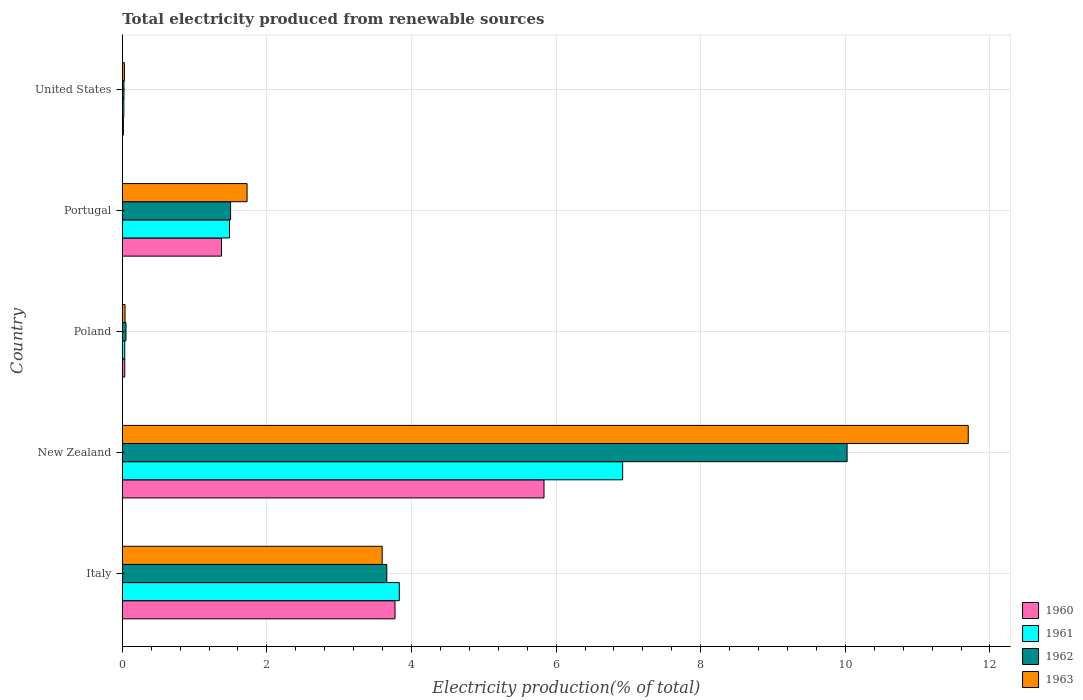How many different coloured bars are there?
Your answer should be compact. 4. How many bars are there on the 4th tick from the bottom?
Keep it short and to the point. 4. What is the label of the 4th group of bars from the top?
Provide a succinct answer. New Zealand. In how many cases, is the number of bars for a given country not equal to the number of legend labels?
Your answer should be compact. 0. What is the total electricity produced in 1963 in Italy?
Provide a succinct answer. 3.59. Across all countries, what is the maximum total electricity produced in 1963?
Your response must be concise. 11.7. Across all countries, what is the minimum total electricity produced in 1961?
Ensure brevity in your answer.  0.02. In which country was the total electricity produced in 1962 maximum?
Your answer should be very brief. New Zealand. In which country was the total electricity produced in 1962 minimum?
Offer a terse response. United States. What is the total total electricity produced in 1963 in the graph?
Your response must be concise. 17.09. What is the difference between the total electricity produced in 1960 in New Zealand and that in United States?
Ensure brevity in your answer.  5.82. What is the difference between the total electricity produced in 1963 in United States and the total electricity produced in 1960 in Italy?
Your answer should be very brief. -3.74. What is the average total electricity produced in 1960 per country?
Ensure brevity in your answer.  2.21. What is the difference between the total electricity produced in 1962 and total electricity produced in 1963 in Portugal?
Your answer should be very brief. -0.23. What is the ratio of the total electricity produced in 1960 in Poland to that in Portugal?
Keep it short and to the point. 0.02. Is the difference between the total electricity produced in 1962 in New Zealand and Poland greater than the difference between the total electricity produced in 1963 in New Zealand and Poland?
Your answer should be compact. No. What is the difference between the highest and the second highest total electricity produced in 1960?
Your response must be concise. 2.06. What is the difference between the highest and the lowest total electricity produced in 1960?
Offer a terse response. 5.82. In how many countries, is the total electricity produced in 1961 greater than the average total electricity produced in 1961 taken over all countries?
Offer a terse response. 2. Is the sum of the total electricity produced in 1963 in Italy and Poland greater than the maximum total electricity produced in 1962 across all countries?
Offer a terse response. No. Is it the case that in every country, the sum of the total electricity produced in 1962 and total electricity produced in 1960 is greater than the sum of total electricity produced in 1961 and total electricity produced in 1963?
Your answer should be very brief. No. Is it the case that in every country, the sum of the total electricity produced in 1963 and total electricity produced in 1960 is greater than the total electricity produced in 1961?
Give a very brief answer. Yes. How many countries are there in the graph?
Your answer should be very brief. 5. What is the difference between two consecutive major ticks on the X-axis?
Your response must be concise. 2. Are the values on the major ticks of X-axis written in scientific E-notation?
Your answer should be compact. No. Does the graph contain grids?
Offer a very short reply. Yes. How are the legend labels stacked?
Make the answer very short. Vertical. What is the title of the graph?
Provide a succinct answer. Total electricity produced from renewable sources. What is the label or title of the X-axis?
Keep it short and to the point. Electricity production(% of total). What is the label or title of the Y-axis?
Your answer should be very brief. Country. What is the Electricity production(% of total) of 1960 in Italy?
Keep it short and to the point. 3.77. What is the Electricity production(% of total) in 1961 in Italy?
Make the answer very short. 3.83. What is the Electricity production(% of total) in 1962 in Italy?
Offer a very short reply. 3.66. What is the Electricity production(% of total) in 1963 in Italy?
Give a very brief answer. 3.59. What is the Electricity production(% of total) of 1960 in New Zealand?
Your response must be concise. 5.83. What is the Electricity production(% of total) in 1961 in New Zealand?
Offer a terse response. 6.92. What is the Electricity production(% of total) in 1962 in New Zealand?
Ensure brevity in your answer.  10.02. What is the Electricity production(% of total) of 1963 in New Zealand?
Give a very brief answer. 11.7. What is the Electricity production(% of total) in 1960 in Poland?
Your answer should be very brief. 0.03. What is the Electricity production(% of total) of 1961 in Poland?
Your response must be concise. 0.03. What is the Electricity production(% of total) of 1962 in Poland?
Provide a succinct answer. 0.05. What is the Electricity production(% of total) of 1963 in Poland?
Keep it short and to the point. 0.04. What is the Electricity production(% of total) in 1960 in Portugal?
Keep it short and to the point. 1.37. What is the Electricity production(% of total) of 1961 in Portugal?
Give a very brief answer. 1.48. What is the Electricity production(% of total) of 1962 in Portugal?
Keep it short and to the point. 1.5. What is the Electricity production(% of total) of 1963 in Portugal?
Your answer should be very brief. 1.73. What is the Electricity production(% of total) in 1960 in United States?
Keep it short and to the point. 0.02. What is the Electricity production(% of total) in 1961 in United States?
Ensure brevity in your answer.  0.02. What is the Electricity production(% of total) in 1962 in United States?
Ensure brevity in your answer.  0.02. What is the Electricity production(% of total) of 1963 in United States?
Make the answer very short. 0.03. Across all countries, what is the maximum Electricity production(% of total) of 1960?
Provide a short and direct response. 5.83. Across all countries, what is the maximum Electricity production(% of total) in 1961?
Give a very brief answer. 6.92. Across all countries, what is the maximum Electricity production(% of total) of 1962?
Your answer should be very brief. 10.02. Across all countries, what is the maximum Electricity production(% of total) in 1963?
Your response must be concise. 11.7. Across all countries, what is the minimum Electricity production(% of total) in 1960?
Offer a very short reply. 0.02. Across all countries, what is the minimum Electricity production(% of total) in 1961?
Keep it short and to the point. 0.02. Across all countries, what is the minimum Electricity production(% of total) in 1962?
Provide a succinct answer. 0.02. Across all countries, what is the minimum Electricity production(% of total) in 1963?
Ensure brevity in your answer.  0.03. What is the total Electricity production(% of total) in 1960 in the graph?
Offer a very short reply. 11.03. What is the total Electricity production(% of total) in 1961 in the graph?
Make the answer very short. 12.29. What is the total Electricity production(% of total) of 1962 in the graph?
Keep it short and to the point. 15.25. What is the total Electricity production(% of total) in 1963 in the graph?
Provide a short and direct response. 17.09. What is the difference between the Electricity production(% of total) in 1960 in Italy and that in New Zealand?
Your response must be concise. -2.06. What is the difference between the Electricity production(% of total) in 1961 in Italy and that in New Zealand?
Make the answer very short. -3.09. What is the difference between the Electricity production(% of total) of 1962 in Italy and that in New Zealand?
Provide a succinct answer. -6.37. What is the difference between the Electricity production(% of total) of 1963 in Italy and that in New Zealand?
Your response must be concise. -8.11. What is the difference between the Electricity production(% of total) of 1960 in Italy and that in Poland?
Offer a very short reply. 3.74. What is the difference between the Electricity production(% of total) of 1961 in Italy and that in Poland?
Your answer should be compact. 3.8. What is the difference between the Electricity production(% of total) of 1962 in Italy and that in Poland?
Keep it short and to the point. 3.61. What is the difference between the Electricity production(% of total) of 1963 in Italy and that in Poland?
Give a very brief answer. 3.56. What is the difference between the Electricity production(% of total) of 1960 in Italy and that in Portugal?
Make the answer very short. 2.4. What is the difference between the Electricity production(% of total) in 1961 in Italy and that in Portugal?
Offer a terse response. 2.35. What is the difference between the Electricity production(% of total) in 1962 in Italy and that in Portugal?
Your answer should be compact. 2.16. What is the difference between the Electricity production(% of total) in 1963 in Italy and that in Portugal?
Make the answer very short. 1.87. What is the difference between the Electricity production(% of total) in 1960 in Italy and that in United States?
Provide a succinct answer. 3.76. What is the difference between the Electricity production(% of total) of 1961 in Italy and that in United States?
Offer a terse response. 3.81. What is the difference between the Electricity production(% of total) in 1962 in Italy and that in United States?
Your answer should be very brief. 3.64. What is the difference between the Electricity production(% of total) in 1963 in Italy and that in United States?
Provide a short and direct response. 3.56. What is the difference between the Electricity production(% of total) of 1960 in New Zealand and that in Poland?
Your answer should be compact. 5.8. What is the difference between the Electricity production(% of total) in 1961 in New Zealand and that in Poland?
Offer a very short reply. 6.89. What is the difference between the Electricity production(% of total) of 1962 in New Zealand and that in Poland?
Give a very brief answer. 9.97. What is the difference between the Electricity production(% of total) of 1963 in New Zealand and that in Poland?
Provide a succinct answer. 11.66. What is the difference between the Electricity production(% of total) of 1960 in New Zealand and that in Portugal?
Give a very brief answer. 4.46. What is the difference between the Electricity production(% of total) in 1961 in New Zealand and that in Portugal?
Your response must be concise. 5.44. What is the difference between the Electricity production(% of total) of 1962 in New Zealand and that in Portugal?
Your answer should be compact. 8.53. What is the difference between the Electricity production(% of total) in 1963 in New Zealand and that in Portugal?
Your answer should be compact. 9.97. What is the difference between the Electricity production(% of total) in 1960 in New Zealand and that in United States?
Your answer should be very brief. 5.82. What is the difference between the Electricity production(% of total) of 1961 in New Zealand and that in United States?
Your answer should be compact. 6.9. What is the difference between the Electricity production(% of total) of 1962 in New Zealand and that in United States?
Ensure brevity in your answer.  10. What is the difference between the Electricity production(% of total) in 1963 in New Zealand and that in United States?
Give a very brief answer. 11.67. What is the difference between the Electricity production(% of total) in 1960 in Poland and that in Portugal?
Provide a succinct answer. -1.34. What is the difference between the Electricity production(% of total) of 1961 in Poland and that in Portugal?
Offer a terse response. -1.45. What is the difference between the Electricity production(% of total) in 1962 in Poland and that in Portugal?
Offer a very short reply. -1.45. What is the difference between the Electricity production(% of total) in 1963 in Poland and that in Portugal?
Make the answer very short. -1.69. What is the difference between the Electricity production(% of total) in 1960 in Poland and that in United States?
Make the answer very short. 0.02. What is the difference between the Electricity production(% of total) in 1961 in Poland and that in United States?
Ensure brevity in your answer.  0.01. What is the difference between the Electricity production(% of total) in 1962 in Poland and that in United States?
Offer a very short reply. 0.03. What is the difference between the Electricity production(% of total) in 1963 in Poland and that in United States?
Ensure brevity in your answer.  0.01. What is the difference between the Electricity production(% of total) of 1960 in Portugal and that in United States?
Make the answer very short. 1.36. What is the difference between the Electricity production(% of total) of 1961 in Portugal and that in United States?
Provide a short and direct response. 1.46. What is the difference between the Electricity production(% of total) of 1962 in Portugal and that in United States?
Make the answer very short. 1.48. What is the difference between the Electricity production(% of total) of 1963 in Portugal and that in United States?
Provide a succinct answer. 1.7. What is the difference between the Electricity production(% of total) in 1960 in Italy and the Electricity production(% of total) in 1961 in New Zealand?
Your answer should be very brief. -3.15. What is the difference between the Electricity production(% of total) of 1960 in Italy and the Electricity production(% of total) of 1962 in New Zealand?
Provide a succinct answer. -6.25. What is the difference between the Electricity production(% of total) of 1960 in Italy and the Electricity production(% of total) of 1963 in New Zealand?
Make the answer very short. -7.93. What is the difference between the Electricity production(% of total) of 1961 in Italy and the Electricity production(% of total) of 1962 in New Zealand?
Provide a short and direct response. -6.19. What is the difference between the Electricity production(% of total) in 1961 in Italy and the Electricity production(% of total) in 1963 in New Zealand?
Offer a very short reply. -7.87. What is the difference between the Electricity production(% of total) of 1962 in Italy and the Electricity production(% of total) of 1963 in New Zealand?
Provide a short and direct response. -8.04. What is the difference between the Electricity production(% of total) in 1960 in Italy and the Electricity production(% of total) in 1961 in Poland?
Provide a short and direct response. 3.74. What is the difference between the Electricity production(% of total) of 1960 in Italy and the Electricity production(% of total) of 1962 in Poland?
Offer a terse response. 3.72. What is the difference between the Electricity production(% of total) of 1960 in Italy and the Electricity production(% of total) of 1963 in Poland?
Provide a succinct answer. 3.73. What is the difference between the Electricity production(% of total) of 1961 in Italy and the Electricity production(% of total) of 1962 in Poland?
Give a very brief answer. 3.78. What is the difference between the Electricity production(% of total) in 1961 in Italy and the Electricity production(% of total) in 1963 in Poland?
Your answer should be very brief. 3.79. What is the difference between the Electricity production(% of total) in 1962 in Italy and the Electricity production(% of total) in 1963 in Poland?
Give a very brief answer. 3.62. What is the difference between the Electricity production(% of total) of 1960 in Italy and the Electricity production(% of total) of 1961 in Portugal?
Make the answer very short. 2.29. What is the difference between the Electricity production(% of total) in 1960 in Italy and the Electricity production(% of total) in 1962 in Portugal?
Make the answer very short. 2.27. What is the difference between the Electricity production(% of total) in 1960 in Italy and the Electricity production(% of total) in 1963 in Portugal?
Your answer should be very brief. 2.05. What is the difference between the Electricity production(% of total) in 1961 in Italy and the Electricity production(% of total) in 1962 in Portugal?
Your answer should be very brief. 2.33. What is the difference between the Electricity production(% of total) in 1961 in Italy and the Electricity production(% of total) in 1963 in Portugal?
Keep it short and to the point. 2.11. What is the difference between the Electricity production(% of total) of 1962 in Italy and the Electricity production(% of total) of 1963 in Portugal?
Provide a succinct answer. 1.93. What is the difference between the Electricity production(% of total) in 1960 in Italy and the Electricity production(% of total) in 1961 in United States?
Your response must be concise. 3.75. What is the difference between the Electricity production(% of total) of 1960 in Italy and the Electricity production(% of total) of 1962 in United States?
Ensure brevity in your answer.  3.75. What is the difference between the Electricity production(% of total) in 1960 in Italy and the Electricity production(% of total) in 1963 in United States?
Ensure brevity in your answer.  3.74. What is the difference between the Electricity production(% of total) in 1961 in Italy and the Electricity production(% of total) in 1962 in United States?
Offer a terse response. 3.81. What is the difference between the Electricity production(% of total) of 1961 in Italy and the Electricity production(% of total) of 1963 in United States?
Your answer should be compact. 3.8. What is the difference between the Electricity production(% of total) in 1962 in Italy and the Electricity production(% of total) in 1963 in United States?
Provide a succinct answer. 3.63. What is the difference between the Electricity production(% of total) in 1960 in New Zealand and the Electricity production(% of total) in 1961 in Poland?
Provide a short and direct response. 5.8. What is the difference between the Electricity production(% of total) in 1960 in New Zealand and the Electricity production(% of total) in 1962 in Poland?
Provide a short and direct response. 5.78. What is the difference between the Electricity production(% of total) in 1960 in New Zealand and the Electricity production(% of total) in 1963 in Poland?
Your answer should be very brief. 5.79. What is the difference between the Electricity production(% of total) of 1961 in New Zealand and the Electricity production(% of total) of 1962 in Poland?
Make the answer very short. 6.87. What is the difference between the Electricity production(% of total) of 1961 in New Zealand and the Electricity production(% of total) of 1963 in Poland?
Your response must be concise. 6.88. What is the difference between the Electricity production(% of total) of 1962 in New Zealand and the Electricity production(% of total) of 1963 in Poland?
Keep it short and to the point. 9.99. What is the difference between the Electricity production(% of total) in 1960 in New Zealand and the Electricity production(% of total) in 1961 in Portugal?
Offer a very short reply. 4.35. What is the difference between the Electricity production(% of total) in 1960 in New Zealand and the Electricity production(% of total) in 1962 in Portugal?
Offer a very short reply. 4.33. What is the difference between the Electricity production(% of total) of 1960 in New Zealand and the Electricity production(% of total) of 1963 in Portugal?
Your answer should be compact. 4.11. What is the difference between the Electricity production(% of total) in 1961 in New Zealand and the Electricity production(% of total) in 1962 in Portugal?
Provide a short and direct response. 5.42. What is the difference between the Electricity production(% of total) of 1961 in New Zealand and the Electricity production(% of total) of 1963 in Portugal?
Provide a short and direct response. 5.19. What is the difference between the Electricity production(% of total) in 1962 in New Zealand and the Electricity production(% of total) in 1963 in Portugal?
Give a very brief answer. 8.3. What is the difference between the Electricity production(% of total) in 1960 in New Zealand and the Electricity production(% of total) in 1961 in United States?
Keep it short and to the point. 5.81. What is the difference between the Electricity production(% of total) in 1960 in New Zealand and the Electricity production(% of total) in 1962 in United States?
Your answer should be compact. 5.81. What is the difference between the Electricity production(% of total) of 1960 in New Zealand and the Electricity production(% of total) of 1963 in United States?
Offer a terse response. 5.8. What is the difference between the Electricity production(% of total) in 1961 in New Zealand and the Electricity production(% of total) in 1962 in United States?
Your answer should be compact. 6.9. What is the difference between the Electricity production(% of total) of 1961 in New Zealand and the Electricity production(% of total) of 1963 in United States?
Ensure brevity in your answer.  6.89. What is the difference between the Electricity production(% of total) of 1962 in New Zealand and the Electricity production(% of total) of 1963 in United States?
Give a very brief answer. 10. What is the difference between the Electricity production(% of total) of 1960 in Poland and the Electricity production(% of total) of 1961 in Portugal?
Provide a succinct answer. -1.45. What is the difference between the Electricity production(% of total) in 1960 in Poland and the Electricity production(% of total) in 1962 in Portugal?
Give a very brief answer. -1.46. What is the difference between the Electricity production(% of total) of 1960 in Poland and the Electricity production(% of total) of 1963 in Portugal?
Provide a succinct answer. -1.69. What is the difference between the Electricity production(% of total) of 1961 in Poland and the Electricity production(% of total) of 1962 in Portugal?
Your answer should be compact. -1.46. What is the difference between the Electricity production(% of total) of 1961 in Poland and the Electricity production(% of total) of 1963 in Portugal?
Give a very brief answer. -1.69. What is the difference between the Electricity production(% of total) of 1962 in Poland and the Electricity production(% of total) of 1963 in Portugal?
Offer a very short reply. -1.67. What is the difference between the Electricity production(% of total) in 1960 in Poland and the Electricity production(% of total) in 1961 in United States?
Keep it short and to the point. 0.01. What is the difference between the Electricity production(% of total) in 1960 in Poland and the Electricity production(% of total) in 1962 in United States?
Provide a short and direct response. 0.01. What is the difference between the Electricity production(% of total) of 1960 in Poland and the Electricity production(% of total) of 1963 in United States?
Make the answer very short. 0. What is the difference between the Electricity production(% of total) of 1961 in Poland and the Electricity production(% of total) of 1962 in United States?
Offer a terse response. 0.01. What is the difference between the Electricity production(% of total) in 1961 in Poland and the Electricity production(% of total) in 1963 in United States?
Ensure brevity in your answer.  0. What is the difference between the Electricity production(% of total) in 1962 in Poland and the Electricity production(% of total) in 1963 in United States?
Your answer should be very brief. 0.02. What is the difference between the Electricity production(% of total) in 1960 in Portugal and the Electricity production(% of total) in 1961 in United States?
Keep it short and to the point. 1.35. What is the difference between the Electricity production(% of total) in 1960 in Portugal and the Electricity production(% of total) in 1962 in United States?
Provide a short and direct response. 1.35. What is the difference between the Electricity production(% of total) of 1960 in Portugal and the Electricity production(% of total) of 1963 in United States?
Your response must be concise. 1.34. What is the difference between the Electricity production(% of total) of 1961 in Portugal and the Electricity production(% of total) of 1962 in United States?
Keep it short and to the point. 1.46. What is the difference between the Electricity production(% of total) in 1961 in Portugal and the Electricity production(% of total) in 1963 in United States?
Provide a short and direct response. 1.45. What is the difference between the Electricity production(% of total) of 1962 in Portugal and the Electricity production(% of total) of 1963 in United States?
Offer a terse response. 1.47. What is the average Electricity production(% of total) in 1960 per country?
Your answer should be compact. 2.21. What is the average Electricity production(% of total) of 1961 per country?
Ensure brevity in your answer.  2.46. What is the average Electricity production(% of total) of 1962 per country?
Provide a succinct answer. 3.05. What is the average Electricity production(% of total) of 1963 per country?
Ensure brevity in your answer.  3.42. What is the difference between the Electricity production(% of total) of 1960 and Electricity production(% of total) of 1961 in Italy?
Your response must be concise. -0.06. What is the difference between the Electricity production(% of total) of 1960 and Electricity production(% of total) of 1962 in Italy?
Provide a short and direct response. 0.11. What is the difference between the Electricity production(% of total) in 1960 and Electricity production(% of total) in 1963 in Italy?
Ensure brevity in your answer.  0.18. What is the difference between the Electricity production(% of total) of 1961 and Electricity production(% of total) of 1962 in Italy?
Your answer should be compact. 0.17. What is the difference between the Electricity production(% of total) in 1961 and Electricity production(% of total) in 1963 in Italy?
Your answer should be very brief. 0.24. What is the difference between the Electricity production(% of total) in 1962 and Electricity production(% of total) in 1963 in Italy?
Offer a very short reply. 0.06. What is the difference between the Electricity production(% of total) of 1960 and Electricity production(% of total) of 1961 in New Zealand?
Offer a terse response. -1.09. What is the difference between the Electricity production(% of total) of 1960 and Electricity production(% of total) of 1962 in New Zealand?
Keep it short and to the point. -4.19. What is the difference between the Electricity production(% of total) in 1960 and Electricity production(% of total) in 1963 in New Zealand?
Give a very brief answer. -5.87. What is the difference between the Electricity production(% of total) in 1961 and Electricity production(% of total) in 1962 in New Zealand?
Your response must be concise. -3.1. What is the difference between the Electricity production(% of total) in 1961 and Electricity production(% of total) in 1963 in New Zealand?
Your response must be concise. -4.78. What is the difference between the Electricity production(% of total) in 1962 and Electricity production(% of total) in 1963 in New Zealand?
Your answer should be compact. -1.68. What is the difference between the Electricity production(% of total) of 1960 and Electricity production(% of total) of 1961 in Poland?
Offer a terse response. 0. What is the difference between the Electricity production(% of total) in 1960 and Electricity production(% of total) in 1962 in Poland?
Offer a very short reply. -0.02. What is the difference between the Electricity production(% of total) in 1960 and Electricity production(% of total) in 1963 in Poland?
Provide a short and direct response. -0. What is the difference between the Electricity production(% of total) of 1961 and Electricity production(% of total) of 1962 in Poland?
Offer a very short reply. -0.02. What is the difference between the Electricity production(% of total) in 1961 and Electricity production(% of total) in 1963 in Poland?
Your answer should be compact. -0. What is the difference between the Electricity production(% of total) of 1962 and Electricity production(% of total) of 1963 in Poland?
Provide a succinct answer. 0.01. What is the difference between the Electricity production(% of total) in 1960 and Electricity production(% of total) in 1961 in Portugal?
Give a very brief answer. -0.11. What is the difference between the Electricity production(% of total) of 1960 and Electricity production(% of total) of 1962 in Portugal?
Make the answer very short. -0.13. What is the difference between the Electricity production(% of total) in 1960 and Electricity production(% of total) in 1963 in Portugal?
Make the answer very short. -0.35. What is the difference between the Electricity production(% of total) in 1961 and Electricity production(% of total) in 1962 in Portugal?
Give a very brief answer. -0.02. What is the difference between the Electricity production(% of total) in 1961 and Electricity production(% of total) in 1963 in Portugal?
Your response must be concise. -0.24. What is the difference between the Electricity production(% of total) of 1962 and Electricity production(% of total) of 1963 in Portugal?
Keep it short and to the point. -0.23. What is the difference between the Electricity production(% of total) of 1960 and Electricity production(% of total) of 1961 in United States?
Make the answer very short. -0.01. What is the difference between the Electricity production(% of total) in 1960 and Electricity production(% of total) in 1962 in United States?
Your answer should be compact. -0.01. What is the difference between the Electricity production(% of total) in 1960 and Electricity production(% of total) in 1963 in United States?
Keep it short and to the point. -0.01. What is the difference between the Electricity production(% of total) of 1961 and Electricity production(% of total) of 1962 in United States?
Provide a succinct answer. -0. What is the difference between the Electricity production(% of total) in 1961 and Electricity production(% of total) in 1963 in United States?
Give a very brief answer. -0.01. What is the difference between the Electricity production(% of total) of 1962 and Electricity production(% of total) of 1963 in United States?
Provide a short and direct response. -0.01. What is the ratio of the Electricity production(% of total) of 1960 in Italy to that in New Zealand?
Offer a very short reply. 0.65. What is the ratio of the Electricity production(% of total) of 1961 in Italy to that in New Zealand?
Give a very brief answer. 0.55. What is the ratio of the Electricity production(% of total) of 1962 in Italy to that in New Zealand?
Offer a terse response. 0.36. What is the ratio of the Electricity production(% of total) in 1963 in Italy to that in New Zealand?
Give a very brief answer. 0.31. What is the ratio of the Electricity production(% of total) in 1960 in Italy to that in Poland?
Ensure brevity in your answer.  110.45. What is the ratio of the Electricity production(% of total) in 1961 in Italy to that in Poland?
Make the answer very short. 112.3. What is the ratio of the Electricity production(% of total) of 1962 in Italy to that in Poland?
Your answer should be very brief. 71.88. What is the ratio of the Electricity production(% of total) of 1963 in Italy to that in Poland?
Provide a short and direct response. 94.84. What is the ratio of the Electricity production(% of total) of 1960 in Italy to that in Portugal?
Keep it short and to the point. 2.75. What is the ratio of the Electricity production(% of total) of 1961 in Italy to that in Portugal?
Provide a succinct answer. 2.58. What is the ratio of the Electricity production(% of total) in 1962 in Italy to that in Portugal?
Make the answer very short. 2.44. What is the ratio of the Electricity production(% of total) in 1963 in Italy to that in Portugal?
Your answer should be very brief. 2.08. What is the ratio of the Electricity production(% of total) of 1960 in Italy to that in United States?
Provide a succinct answer. 247.25. What is the ratio of the Electricity production(% of total) in 1961 in Italy to that in United States?
Give a very brief answer. 177.87. What is the ratio of the Electricity production(% of total) of 1962 in Italy to that in United States?
Your answer should be compact. 160.56. What is the ratio of the Electricity production(% of total) in 1963 in Italy to that in United States?
Your answer should be compact. 122.12. What is the ratio of the Electricity production(% of total) in 1960 in New Zealand to that in Poland?
Provide a succinct answer. 170.79. What is the ratio of the Electricity production(% of total) in 1961 in New Zealand to that in Poland?
Provide a succinct answer. 202.83. What is the ratio of the Electricity production(% of total) in 1962 in New Zealand to that in Poland?
Make the answer very short. 196.95. What is the ratio of the Electricity production(% of total) of 1963 in New Zealand to that in Poland?
Give a very brief answer. 308.73. What is the ratio of the Electricity production(% of total) of 1960 in New Zealand to that in Portugal?
Make the answer very short. 4.25. What is the ratio of the Electricity production(% of total) in 1961 in New Zealand to that in Portugal?
Offer a terse response. 4.67. What is the ratio of the Electricity production(% of total) of 1962 in New Zealand to that in Portugal?
Offer a very short reply. 6.69. What is the ratio of the Electricity production(% of total) of 1963 in New Zealand to that in Portugal?
Keep it short and to the point. 6.78. What is the ratio of the Electricity production(% of total) of 1960 in New Zealand to that in United States?
Keep it short and to the point. 382.31. What is the ratio of the Electricity production(% of total) of 1961 in New Zealand to that in United States?
Provide a short and direct response. 321.25. What is the ratio of the Electricity production(% of total) in 1962 in New Zealand to that in United States?
Your answer should be very brief. 439.93. What is the ratio of the Electricity production(% of total) of 1963 in New Zealand to that in United States?
Offer a terse response. 397.5. What is the ratio of the Electricity production(% of total) of 1960 in Poland to that in Portugal?
Offer a terse response. 0.02. What is the ratio of the Electricity production(% of total) in 1961 in Poland to that in Portugal?
Give a very brief answer. 0.02. What is the ratio of the Electricity production(% of total) in 1962 in Poland to that in Portugal?
Give a very brief answer. 0.03. What is the ratio of the Electricity production(% of total) of 1963 in Poland to that in Portugal?
Provide a succinct answer. 0.02. What is the ratio of the Electricity production(% of total) of 1960 in Poland to that in United States?
Your response must be concise. 2.24. What is the ratio of the Electricity production(% of total) in 1961 in Poland to that in United States?
Make the answer very short. 1.58. What is the ratio of the Electricity production(% of total) of 1962 in Poland to that in United States?
Your answer should be compact. 2.23. What is the ratio of the Electricity production(% of total) of 1963 in Poland to that in United States?
Offer a very short reply. 1.29. What is the ratio of the Electricity production(% of total) of 1960 in Portugal to that in United States?
Your answer should be very brief. 89.96. What is the ratio of the Electricity production(% of total) of 1961 in Portugal to that in United States?
Your answer should be compact. 68.83. What is the ratio of the Electricity production(% of total) in 1962 in Portugal to that in United States?
Ensure brevity in your answer.  65.74. What is the ratio of the Electricity production(% of total) of 1963 in Portugal to that in United States?
Give a very brief answer. 58.63. What is the difference between the highest and the second highest Electricity production(% of total) in 1960?
Offer a terse response. 2.06. What is the difference between the highest and the second highest Electricity production(% of total) in 1961?
Provide a succinct answer. 3.09. What is the difference between the highest and the second highest Electricity production(% of total) of 1962?
Keep it short and to the point. 6.37. What is the difference between the highest and the second highest Electricity production(% of total) of 1963?
Your answer should be very brief. 8.11. What is the difference between the highest and the lowest Electricity production(% of total) of 1960?
Provide a succinct answer. 5.82. What is the difference between the highest and the lowest Electricity production(% of total) in 1961?
Ensure brevity in your answer.  6.9. What is the difference between the highest and the lowest Electricity production(% of total) of 1962?
Your answer should be compact. 10. What is the difference between the highest and the lowest Electricity production(% of total) of 1963?
Your answer should be compact. 11.67. 